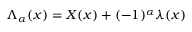Convert formula to latex. <formula><loc_0><loc_0><loc_500><loc_500>{ \Lambda } _ { \alpha } ( x ) = X ( x ) + ( - 1 ) ^ { \alpha } { \lambda } ( x )</formula> 